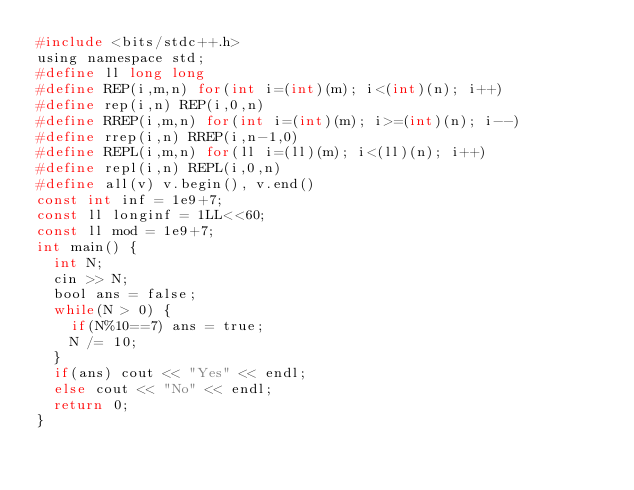Convert code to text. <code><loc_0><loc_0><loc_500><loc_500><_C_>#include <bits/stdc++.h>
using namespace std;
#define ll long long
#define REP(i,m,n) for(int i=(int)(m); i<(int)(n); i++)
#define rep(i,n) REP(i,0,n)
#define RREP(i,m,n) for(int i=(int)(m); i>=(int)(n); i--)
#define rrep(i,n) RREP(i,n-1,0)
#define REPL(i,m,n) for(ll i=(ll)(m); i<(ll)(n); i++)
#define repl(i,n) REPL(i,0,n)
#define all(v) v.begin(), v.end()
const int inf = 1e9+7;
const ll longinf = 1LL<<60;
const ll mod = 1e9+7;
int main() {
  int N;
  cin >> N;
  bool ans = false;
  while(N > 0) {
    if(N%10==7) ans = true;
    N /= 10;
  }
  if(ans) cout << "Yes" << endl;
  else cout << "No" << endl;
  return 0;
}
</code> 